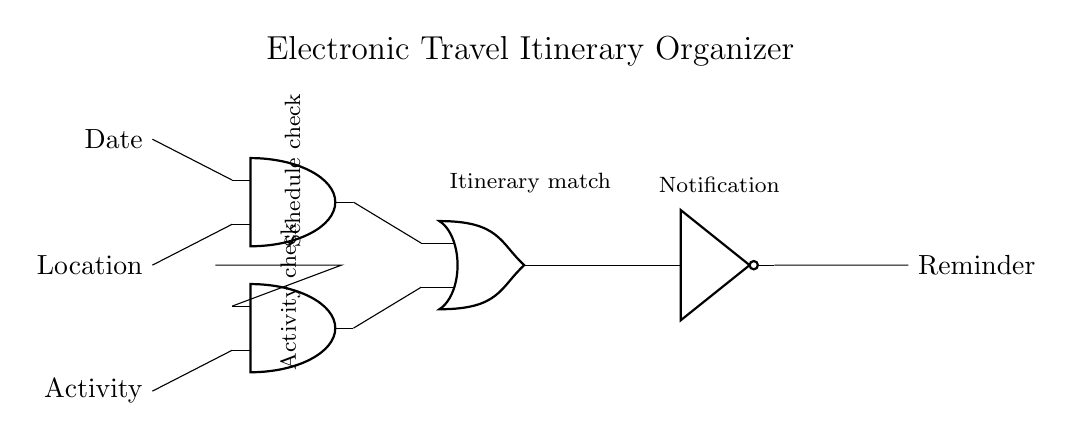What are the inputs for this circuit? The inputs are Date, Location, and Activity, which are connected to different parts of the circuit. The Date and Location are inputs to the first AND gate and the Activity is an input to the second AND gate.
Answer: Date, Location, Activity How many gates are in this circuit? There are four gates: two AND gates, one OR gate, and one NOT gate. They each serve to process the inputs differently as per logical operations.
Answer: Four What triggers the Reminder output? The Reminder output is triggered when the AND gates receive the appropriate inputs, which pass through the OR gate and then are inverted by the NOT gate.
Answer: AND and OR gates What is the function of the NOT gate in this circuit? The NOT gate inverts the output of the OR gate, meaning if the OR gate outputs a true signal, the NOT gate will output a false signal, and vice versa, which adjusts the final reminder logic.
Answer: Inversion What needs to happen for the first AND gate to output a signal? The first AND gate requires both Date and Location inputs to be true; if either is false, the output remains false and does not propagate to the OR gate.
Answer: Date and Location must be true When does the Activity check occur in this circuit? The Activity check occurs when the signal from the Activity input is connected to the second AND gate, which then checks its input state alongside the verification from the first AND gate before outputting to the OR gate.
Answer: Activity in the second AND gate 